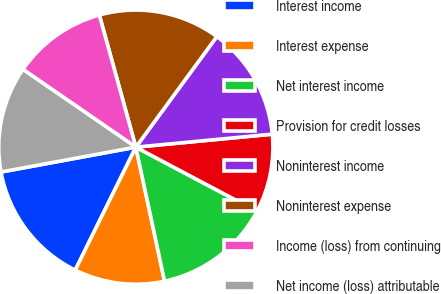<chart> <loc_0><loc_0><loc_500><loc_500><pie_chart><fcel>Interest income<fcel>Interest expense<fcel>Net interest income<fcel>Provision for credit losses<fcel>Noninterest income<fcel>Noninterest expense<fcel>Income (loss) from continuing<fcel>Net income (loss) attributable<nl><fcel>14.81%<fcel>10.65%<fcel>13.89%<fcel>9.26%<fcel>13.43%<fcel>14.35%<fcel>11.11%<fcel>12.5%<nl></chart> 